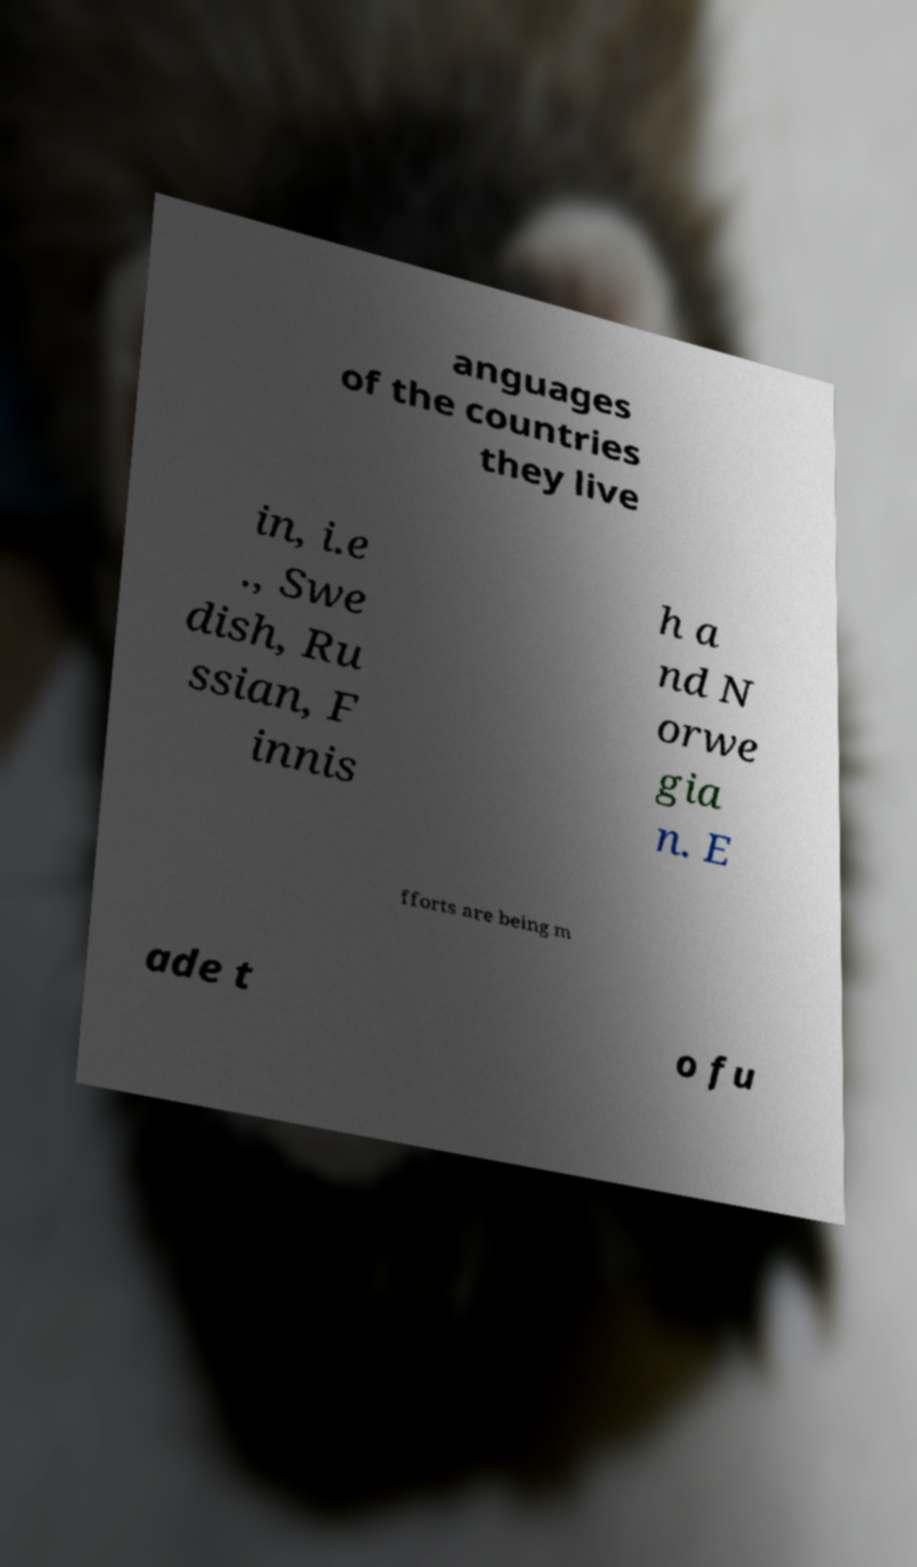Can you read and provide the text displayed in the image?This photo seems to have some interesting text. Can you extract and type it out for me? anguages of the countries they live in, i.e ., Swe dish, Ru ssian, F innis h a nd N orwe gia n. E fforts are being m ade t o fu 